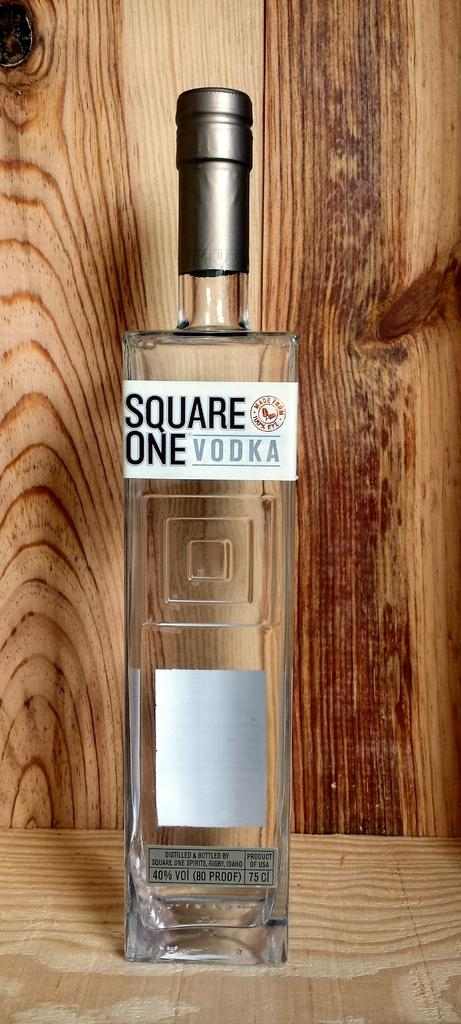<image>
Give a short and clear explanation of the subsequent image. A bottle of square one vodka is displayed on a wooden crate. 